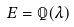Convert formula to latex. <formula><loc_0><loc_0><loc_500><loc_500>E = \mathbb { Q } ( \lambda )</formula> 